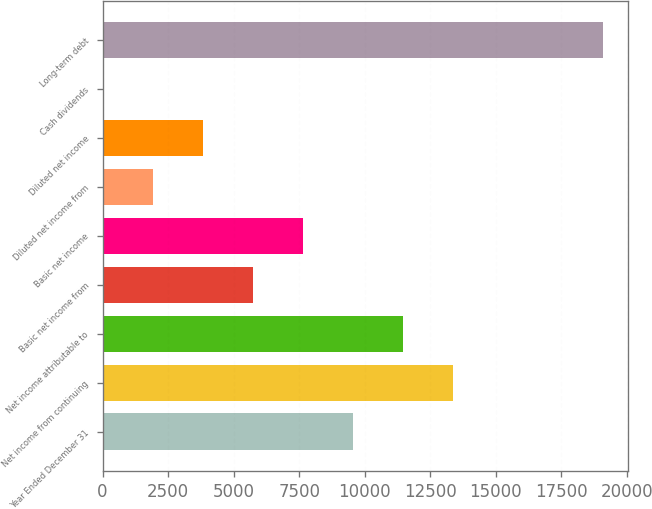Convert chart. <chart><loc_0><loc_0><loc_500><loc_500><bar_chart><fcel>Year Ended December 31<fcel>Net income from continuing<fcel>Net income attributable to<fcel>Basic net income from<fcel>Basic net income<fcel>Diluted net income from<fcel>Diluted net income<fcel>Cash dividends<fcel>Long-term debt<nl><fcel>9551.07<fcel>13371<fcel>11461.1<fcel>5731.09<fcel>7641.08<fcel>1911.11<fcel>3821.1<fcel>1.12<fcel>19101<nl></chart> 